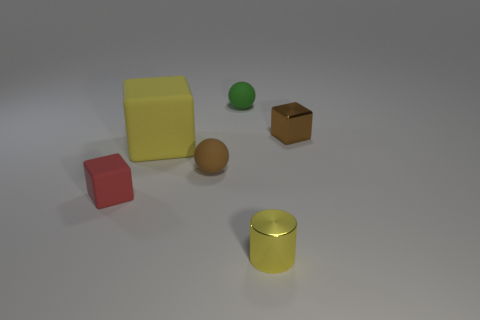There is a brown object in front of the large cube; what material is it? The brown object appears to resemble a cardboard box, which commonly has a fluted paper layer encased between two sheets of liner paper, and is widely used for packaging due to its lightweight and sturdy structure. 